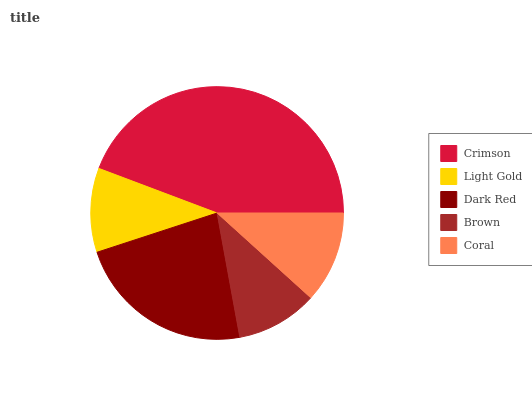Is Brown the minimum?
Answer yes or no. Yes. Is Crimson the maximum?
Answer yes or no. Yes. Is Light Gold the minimum?
Answer yes or no. No. Is Light Gold the maximum?
Answer yes or no. No. Is Crimson greater than Light Gold?
Answer yes or no. Yes. Is Light Gold less than Crimson?
Answer yes or no. Yes. Is Light Gold greater than Crimson?
Answer yes or no. No. Is Crimson less than Light Gold?
Answer yes or no. No. Is Coral the high median?
Answer yes or no. Yes. Is Coral the low median?
Answer yes or no. Yes. Is Light Gold the high median?
Answer yes or no. No. Is Crimson the low median?
Answer yes or no. No. 